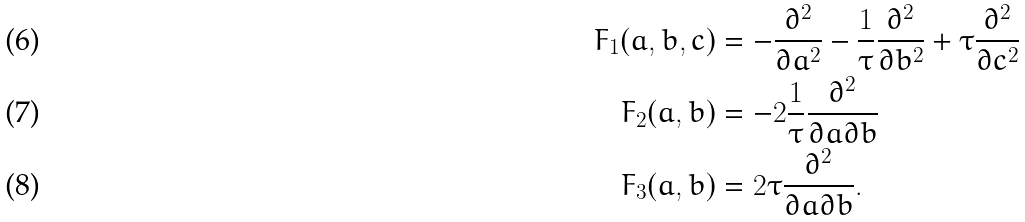Convert formula to latex. <formula><loc_0><loc_0><loc_500><loc_500>F _ { 1 } ( a , b , c ) & = - \frac { \partial ^ { 2 } } { \partial { a } ^ { 2 } } - \frac { 1 } { \tau } \frac { \partial ^ { 2 } } { \partial { b } ^ { 2 } } + \tau \frac { \partial ^ { 2 } } { \partial { c } ^ { 2 } } \\ F _ { 2 } ( a , b ) & = - 2 \frac { 1 } { \tau } \frac { \partial ^ { 2 } } { \partial { a } \partial { b } } \\ F _ { 3 } ( a , b ) & = 2 \tau \frac { \partial ^ { 2 } } { \partial { a } \partial { b } } .</formula> 